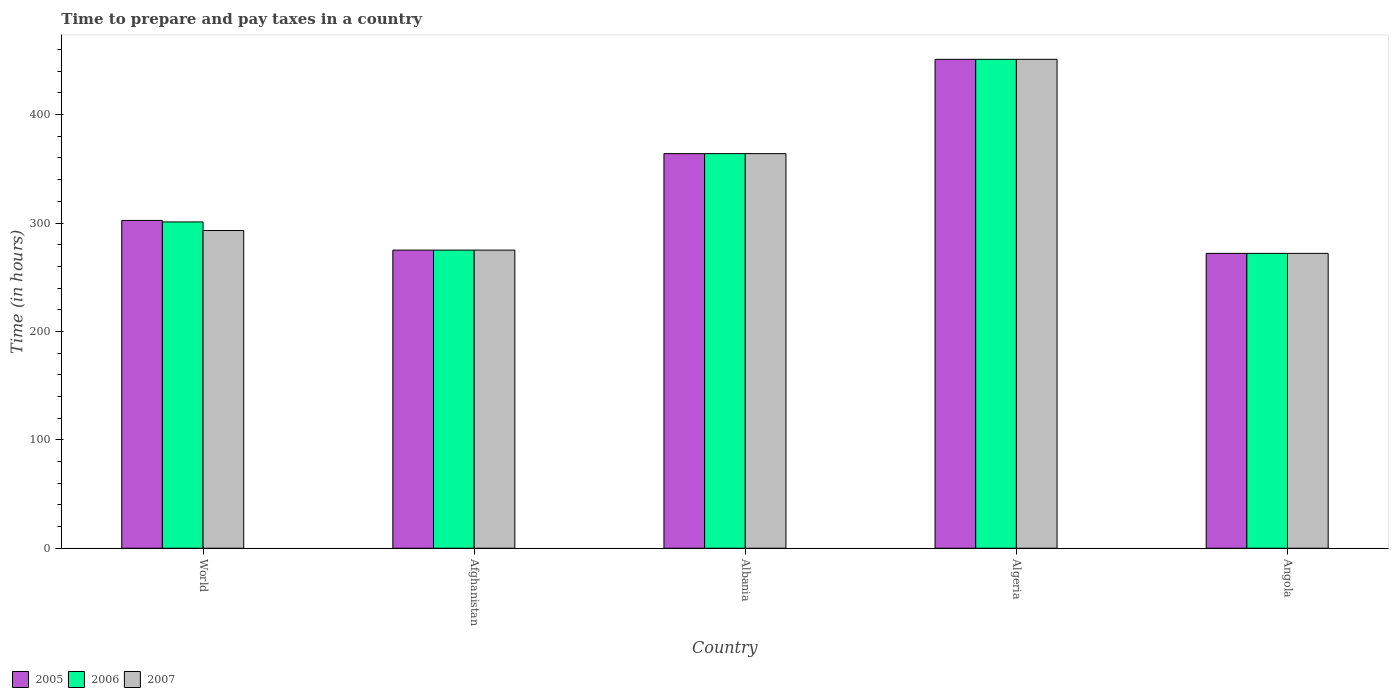How many different coloured bars are there?
Keep it short and to the point. 3. How many groups of bars are there?
Offer a terse response. 5. How many bars are there on the 1st tick from the right?
Provide a short and direct response. 3. What is the label of the 5th group of bars from the left?
Your answer should be compact. Angola. What is the number of hours required to prepare and pay taxes in 2005 in Algeria?
Give a very brief answer. 451. Across all countries, what is the maximum number of hours required to prepare and pay taxes in 2005?
Give a very brief answer. 451. Across all countries, what is the minimum number of hours required to prepare and pay taxes in 2005?
Your answer should be compact. 272. In which country was the number of hours required to prepare and pay taxes in 2006 maximum?
Offer a very short reply. Algeria. In which country was the number of hours required to prepare and pay taxes in 2006 minimum?
Your response must be concise. Angola. What is the total number of hours required to prepare and pay taxes in 2007 in the graph?
Your answer should be very brief. 1655.08. What is the difference between the number of hours required to prepare and pay taxes in 2007 in Afghanistan and that in Albania?
Your response must be concise. -89. What is the difference between the number of hours required to prepare and pay taxes in 2007 in Albania and the number of hours required to prepare and pay taxes in 2006 in Angola?
Provide a succinct answer. 92. What is the average number of hours required to prepare and pay taxes in 2007 per country?
Make the answer very short. 331.02. What is the difference between the number of hours required to prepare and pay taxes of/in 2007 and number of hours required to prepare and pay taxes of/in 2005 in Algeria?
Make the answer very short. 0. In how many countries, is the number of hours required to prepare and pay taxes in 2006 greater than 100 hours?
Offer a terse response. 5. What is the ratio of the number of hours required to prepare and pay taxes in 2005 in Afghanistan to that in World?
Offer a terse response. 0.91. What is the difference between the highest and the second highest number of hours required to prepare and pay taxes in 2005?
Provide a succinct answer. 87. What is the difference between the highest and the lowest number of hours required to prepare and pay taxes in 2006?
Offer a very short reply. 179. In how many countries, is the number of hours required to prepare and pay taxes in 2007 greater than the average number of hours required to prepare and pay taxes in 2007 taken over all countries?
Offer a very short reply. 2. Is the sum of the number of hours required to prepare and pay taxes in 2007 in Afghanistan and Angola greater than the maximum number of hours required to prepare and pay taxes in 2005 across all countries?
Offer a very short reply. Yes. What does the 3rd bar from the left in World represents?
Keep it short and to the point. 2007. What does the 1st bar from the right in Angola represents?
Your answer should be compact. 2007. How many bars are there?
Offer a very short reply. 15. Are all the bars in the graph horizontal?
Offer a very short reply. No. How many countries are there in the graph?
Offer a very short reply. 5. What is the difference between two consecutive major ticks on the Y-axis?
Your answer should be compact. 100. Does the graph contain any zero values?
Your response must be concise. No. Where does the legend appear in the graph?
Your response must be concise. Bottom left. How many legend labels are there?
Your response must be concise. 3. How are the legend labels stacked?
Provide a succinct answer. Horizontal. What is the title of the graph?
Provide a succinct answer. Time to prepare and pay taxes in a country. Does "1981" appear as one of the legend labels in the graph?
Keep it short and to the point. No. What is the label or title of the X-axis?
Provide a short and direct response. Country. What is the label or title of the Y-axis?
Your response must be concise. Time (in hours). What is the Time (in hours) of 2005 in World?
Provide a succinct answer. 302.39. What is the Time (in hours) in 2006 in World?
Your response must be concise. 301.01. What is the Time (in hours) in 2007 in World?
Offer a terse response. 293.08. What is the Time (in hours) in 2005 in Afghanistan?
Your answer should be very brief. 275. What is the Time (in hours) in 2006 in Afghanistan?
Provide a short and direct response. 275. What is the Time (in hours) of 2007 in Afghanistan?
Keep it short and to the point. 275. What is the Time (in hours) in 2005 in Albania?
Offer a terse response. 364. What is the Time (in hours) in 2006 in Albania?
Offer a very short reply. 364. What is the Time (in hours) in 2007 in Albania?
Your answer should be very brief. 364. What is the Time (in hours) in 2005 in Algeria?
Your response must be concise. 451. What is the Time (in hours) in 2006 in Algeria?
Give a very brief answer. 451. What is the Time (in hours) in 2007 in Algeria?
Keep it short and to the point. 451. What is the Time (in hours) of 2005 in Angola?
Provide a succinct answer. 272. What is the Time (in hours) of 2006 in Angola?
Offer a terse response. 272. What is the Time (in hours) of 2007 in Angola?
Make the answer very short. 272. Across all countries, what is the maximum Time (in hours) in 2005?
Provide a succinct answer. 451. Across all countries, what is the maximum Time (in hours) in 2006?
Offer a terse response. 451. Across all countries, what is the maximum Time (in hours) in 2007?
Provide a short and direct response. 451. Across all countries, what is the minimum Time (in hours) of 2005?
Provide a short and direct response. 272. Across all countries, what is the minimum Time (in hours) of 2006?
Your response must be concise. 272. Across all countries, what is the minimum Time (in hours) in 2007?
Give a very brief answer. 272. What is the total Time (in hours) of 2005 in the graph?
Provide a short and direct response. 1664.39. What is the total Time (in hours) of 2006 in the graph?
Offer a terse response. 1663.01. What is the total Time (in hours) in 2007 in the graph?
Provide a short and direct response. 1655.08. What is the difference between the Time (in hours) of 2005 in World and that in Afghanistan?
Provide a short and direct response. 27.39. What is the difference between the Time (in hours) of 2006 in World and that in Afghanistan?
Provide a short and direct response. 26.01. What is the difference between the Time (in hours) in 2007 in World and that in Afghanistan?
Offer a very short reply. 18.08. What is the difference between the Time (in hours) of 2005 in World and that in Albania?
Your answer should be very brief. -61.61. What is the difference between the Time (in hours) of 2006 in World and that in Albania?
Your answer should be compact. -62.99. What is the difference between the Time (in hours) in 2007 in World and that in Albania?
Your response must be concise. -70.92. What is the difference between the Time (in hours) of 2005 in World and that in Algeria?
Make the answer very short. -148.61. What is the difference between the Time (in hours) in 2006 in World and that in Algeria?
Your answer should be very brief. -149.99. What is the difference between the Time (in hours) in 2007 in World and that in Algeria?
Your answer should be very brief. -157.92. What is the difference between the Time (in hours) in 2005 in World and that in Angola?
Give a very brief answer. 30.39. What is the difference between the Time (in hours) in 2006 in World and that in Angola?
Your answer should be very brief. 29.01. What is the difference between the Time (in hours) in 2007 in World and that in Angola?
Make the answer very short. 21.08. What is the difference between the Time (in hours) of 2005 in Afghanistan and that in Albania?
Give a very brief answer. -89. What is the difference between the Time (in hours) of 2006 in Afghanistan and that in Albania?
Keep it short and to the point. -89. What is the difference between the Time (in hours) in 2007 in Afghanistan and that in Albania?
Your answer should be compact. -89. What is the difference between the Time (in hours) of 2005 in Afghanistan and that in Algeria?
Give a very brief answer. -176. What is the difference between the Time (in hours) of 2006 in Afghanistan and that in Algeria?
Ensure brevity in your answer.  -176. What is the difference between the Time (in hours) of 2007 in Afghanistan and that in Algeria?
Make the answer very short. -176. What is the difference between the Time (in hours) in 2007 in Afghanistan and that in Angola?
Offer a very short reply. 3. What is the difference between the Time (in hours) of 2005 in Albania and that in Algeria?
Offer a very short reply. -87. What is the difference between the Time (in hours) of 2006 in Albania and that in Algeria?
Provide a succinct answer. -87. What is the difference between the Time (in hours) of 2007 in Albania and that in Algeria?
Your answer should be very brief. -87. What is the difference between the Time (in hours) of 2005 in Albania and that in Angola?
Provide a succinct answer. 92. What is the difference between the Time (in hours) in 2006 in Albania and that in Angola?
Offer a terse response. 92. What is the difference between the Time (in hours) of 2007 in Albania and that in Angola?
Provide a short and direct response. 92. What is the difference between the Time (in hours) of 2005 in Algeria and that in Angola?
Keep it short and to the point. 179. What is the difference between the Time (in hours) in 2006 in Algeria and that in Angola?
Provide a short and direct response. 179. What is the difference between the Time (in hours) of 2007 in Algeria and that in Angola?
Your answer should be very brief. 179. What is the difference between the Time (in hours) in 2005 in World and the Time (in hours) in 2006 in Afghanistan?
Offer a terse response. 27.39. What is the difference between the Time (in hours) of 2005 in World and the Time (in hours) of 2007 in Afghanistan?
Offer a terse response. 27.39. What is the difference between the Time (in hours) in 2006 in World and the Time (in hours) in 2007 in Afghanistan?
Your answer should be compact. 26.01. What is the difference between the Time (in hours) of 2005 in World and the Time (in hours) of 2006 in Albania?
Offer a terse response. -61.61. What is the difference between the Time (in hours) in 2005 in World and the Time (in hours) in 2007 in Albania?
Your answer should be very brief. -61.61. What is the difference between the Time (in hours) of 2006 in World and the Time (in hours) of 2007 in Albania?
Give a very brief answer. -62.99. What is the difference between the Time (in hours) of 2005 in World and the Time (in hours) of 2006 in Algeria?
Keep it short and to the point. -148.61. What is the difference between the Time (in hours) in 2005 in World and the Time (in hours) in 2007 in Algeria?
Provide a succinct answer. -148.61. What is the difference between the Time (in hours) of 2006 in World and the Time (in hours) of 2007 in Algeria?
Your answer should be very brief. -149.99. What is the difference between the Time (in hours) in 2005 in World and the Time (in hours) in 2006 in Angola?
Provide a succinct answer. 30.39. What is the difference between the Time (in hours) of 2005 in World and the Time (in hours) of 2007 in Angola?
Offer a very short reply. 30.39. What is the difference between the Time (in hours) of 2006 in World and the Time (in hours) of 2007 in Angola?
Provide a succinct answer. 29.01. What is the difference between the Time (in hours) of 2005 in Afghanistan and the Time (in hours) of 2006 in Albania?
Your response must be concise. -89. What is the difference between the Time (in hours) of 2005 in Afghanistan and the Time (in hours) of 2007 in Albania?
Your response must be concise. -89. What is the difference between the Time (in hours) of 2006 in Afghanistan and the Time (in hours) of 2007 in Albania?
Offer a terse response. -89. What is the difference between the Time (in hours) of 2005 in Afghanistan and the Time (in hours) of 2006 in Algeria?
Your response must be concise. -176. What is the difference between the Time (in hours) in 2005 in Afghanistan and the Time (in hours) in 2007 in Algeria?
Offer a very short reply. -176. What is the difference between the Time (in hours) of 2006 in Afghanistan and the Time (in hours) of 2007 in Algeria?
Keep it short and to the point. -176. What is the difference between the Time (in hours) of 2005 in Afghanistan and the Time (in hours) of 2007 in Angola?
Your answer should be compact. 3. What is the difference between the Time (in hours) of 2006 in Afghanistan and the Time (in hours) of 2007 in Angola?
Your answer should be compact. 3. What is the difference between the Time (in hours) in 2005 in Albania and the Time (in hours) in 2006 in Algeria?
Your answer should be very brief. -87. What is the difference between the Time (in hours) of 2005 in Albania and the Time (in hours) of 2007 in Algeria?
Provide a succinct answer. -87. What is the difference between the Time (in hours) of 2006 in Albania and the Time (in hours) of 2007 in Algeria?
Offer a very short reply. -87. What is the difference between the Time (in hours) of 2005 in Albania and the Time (in hours) of 2006 in Angola?
Offer a very short reply. 92. What is the difference between the Time (in hours) of 2005 in Albania and the Time (in hours) of 2007 in Angola?
Offer a terse response. 92. What is the difference between the Time (in hours) of 2006 in Albania and the Time (in hours) of 2007 in Angola?
Make the answer very short. 92. What is the difference between the Time (in hours) in 2005 in Algeria and the Time (in hours) in 2006 in Angola?
Offer a very short reply. 179. What is the difference between the Time (in hours) in 2005 in Algeria and the Time (in hours) in 2007 in Angola?
Ensure brevity in your answer.  179. What is the difference between the Time (in hours) in 2006 in Algeria and the Time (in hours) in 2007 in Angola?
Your response must be concise. 179. What is the average Time (in hours) in 2005 per country?
Offer a very short reply. 332.88. What is the average Time (in hours) in 2006 per country?
Make the answer very short. 332.6. What is the average Time (in hours) in 2007 per country?
Keep it short and to the point. 331.02. What is the difference between the Time (in hours) of 2005 and Time (in hours) of 2006 in World?
Keep it short and to the point. 1.38. What is the difference between the Time (in hours) of 2005 and Time (in hours) of 2007 in World?
Provide a succinct answer. 9.32. What is the difference between the Time (in hours) in 2006 and Time (in hours) in 2007 in World?
Make the answer very short. 7.93. What is the difference between the Time (in hours) in 2005 and Time (in hours) in 2006 in Afghanistan?
Your answer should be compact. 0. What is the difference between the Time (in hours) in 2005 and Time (in hours) in 2007 in Afghanistan?
Provide a short and direct response. 0. What is the difference between the Time (in hours) in 2006 and Time (in hours) in 2007 in Afghanistan?
Your response must be concise. 0. What is the difference between the Time (in hours) in 2005 and Time (in hours) in 2006 in Albania?
Your answer should be compact. 0. What is the difference between the Time (in hours) in 2005 and Time (in hours) in 2007 in Albania?
Provide a short and direct response. 0. What is the difference between the Time (in hours) in 2006 and Time (in hours) in 2007 in Albania?
Ensure brevity in your answer.  0. What is the difference between the Time (in hours) of 2006 and Time (in hours) of 2007 in Algeria?
Keep it short and to the point. 0. What is the difference between the Time (in hours) of 2005 and Time (in hours) of 2006 in Angola?
Provide a short and direct response. 0. What is the difference between the Time (in hours) of 2006 and Time (in hours) of 2007 in Angola?
Your answer should be compact. 0. What is the ratio of the Time (in hours) of 2005 in World to that in Afghanistan?
Your answer should be compact. 1.1. What is the ratio of the Time (in hours) in 2006 in World to that in Afghanistan?
Offer a terse response. 1.09. What is the ratio of the Time (in hours) of 2007 in World to that in Afghanistan?
Provide a succinct answer. 1.07. What is the ratio of the Time (in hours) of 2005 in World to that in Albania?
Your answer should be very brief. 0.83. What is the ratio of the Time (in hours) in 2006 in World to that in Albania?
Give a very brief answer. 0.83. What is the ratio of the Time (in hours) in 2007 in World to that in Albania?
Ensure brevity in your answer.  0.81. What is the ratio of the Time (in hours) of 2005 in World to that in Algeria?
Your response must be concise. 0.67. What is the ratio of the Time (in hours) of 2006 in World to that in Algeria?
Your answer should be compact. 0.67. What is the ratio of the Time (in hours) of 2007 in World to that in Algeria?
Give a very brief answer. 0.65. What is the ratio of the Time (in hours) of 2005 in World to that in Angola?
Your answer should be very brief. 1.11. What is the ratio of the Time (in hours) in 2006 in World to that in Angola?
Ensure brevity in your answer.  1.11. What is the ratio of the Time (in hours) of 2007 in World to that in Angola?
Provide a short and direct response. 1.08. What is the ratio of the Time (in hours) of 2005 in Afghanistan to that in Albania?
Keep it short and to the point. 0.76. What is the ratio of the Time (in hours) in 2006 in Afghanistan to that in Albania?
Your response must be concise. 0.76. What is the ratio of the Time (in hours) of 2007 in Afghanistan to that in Albania?
Your response must be concise. 0.76. What is the ratio of the Time (in hours) in 2005 in Afghanistan to that in Algeria?
Your answer should be very brief. 0.61. What is the ratio of the Time (in hours) of 2006 in Afghanistan to that in Algeria?
Ensure brevity in your answer.  0.61. What is the ratio of the Time (in hours) in 2007 in Afghanistan to that in Algeria?
Provide a short and direct response. 0.61. What is the ratio of the Time (in hours) in 2005 in Albania to that in Algeria?
Give a very brief answer. 0.81. What is the ratio of the Time (in hours) in 2006 in Albania to that in Algeria?
Ensure brevity in your answer.  0.81. What is the ratio of the Time (in hours) in 2007 in Albania to that in Algeria?
Your answer should be compact. 0.81. What is the ratio of the Time (in hours) in 2005 in Albania to that in Angola?
Provide a short and direct response. 1.34. What is the ratio of the Time (in hours) in 2006 in Albania to that in Angola?
Make the answer very short. 1.34. What is the ratio of the Time (in hours) of 2007 in Albania to that in Angola?
Your answer should be very brief. 1.34. What is the ratio of the Time (in hours) in 2005 in Algeria to that in Angola?
Offer a terse response. 1.66. What is the ratio of the Time (in hours) of 2006 in Algeria to that in Angola?
Your response must be concise. 1.66. What is the ratio of the Time (in hours) in 2007 in Algeria to that in Angola?
Keep it short and to the point. 1.66. What is the difference between the highest and the second highest Time (in hours) of 2005?
Your answer should be very brief. 87. What is the difference between the highest and the lowest Time (in hours) in 2005?
Give a very brief answer. 179. What is the difference between the highest and the lowest Time (in hours) in 2006?
Offer a terse response. 179. What is the difference between the highest and the lowest Time (in hours) in 2007?
Offer a very short reply. 179. 